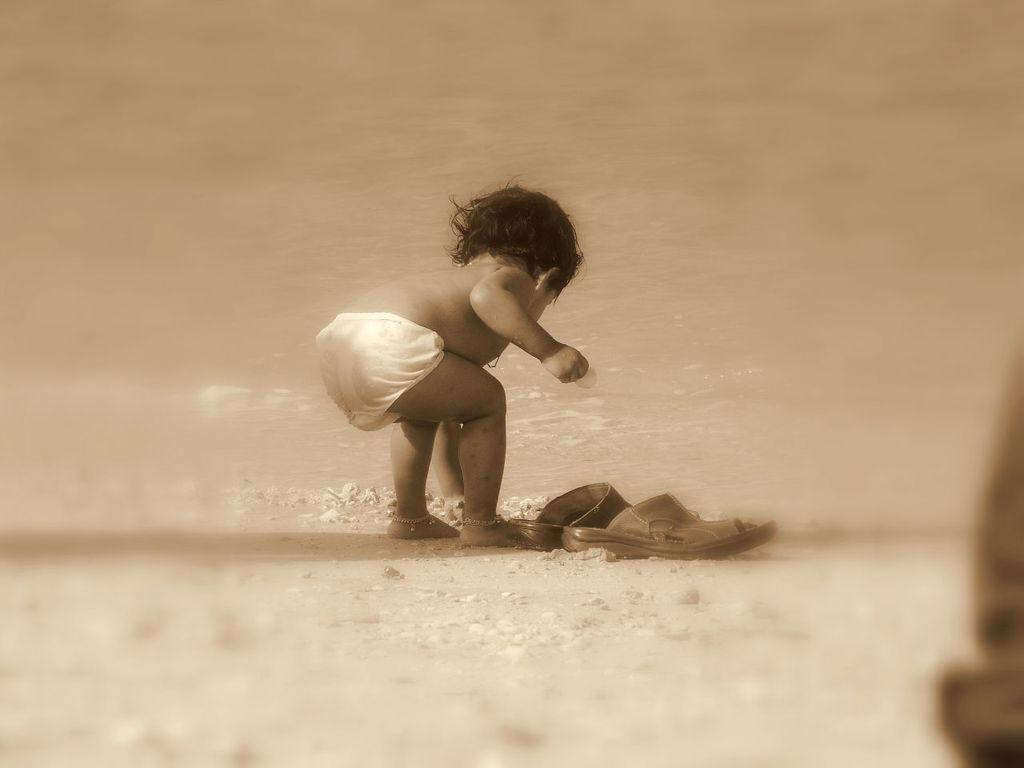What is the main subject of the image? There is a baby in the center of the image. Where is the baby located in the image? The baby is standing on the road. What can be seen in front of the baby? There are footwear in front of the baby. What type of thunder can be heard in the image? There is no mention of thunder or any sound in the image, so it cannot be determined from the image. 